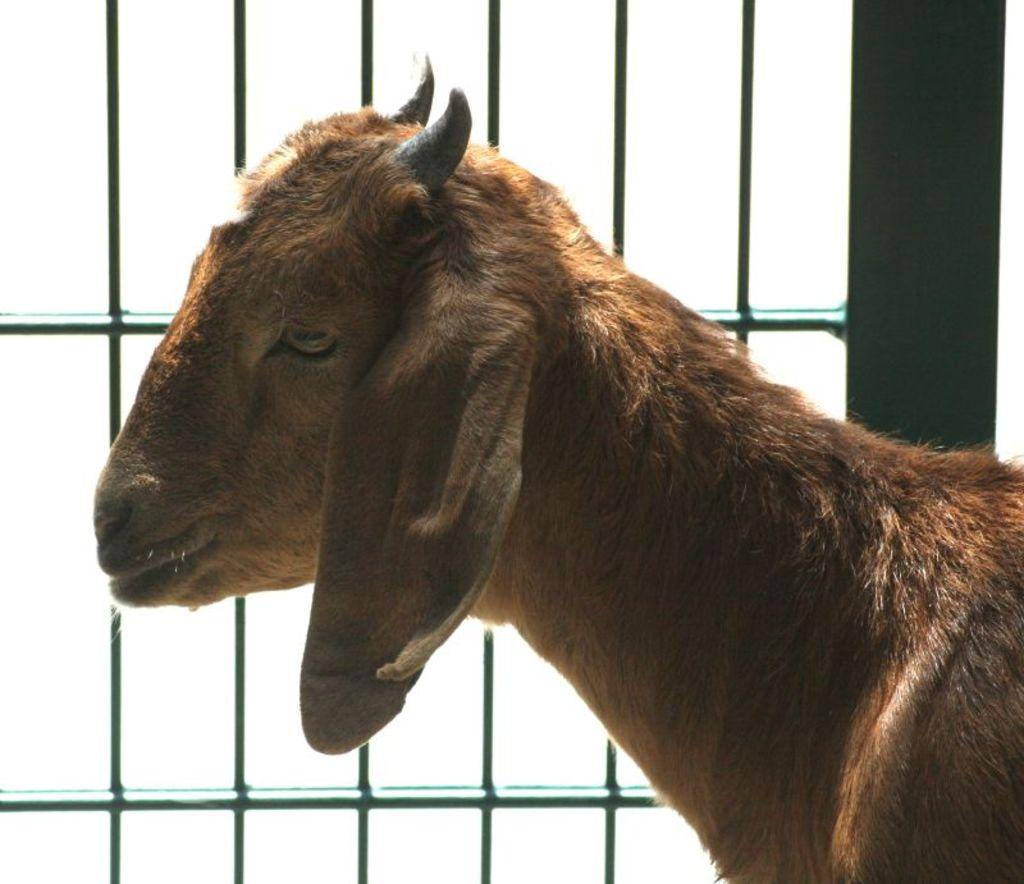What animal is in the picture? There is a goat in the picture. What is the color of the goat? The goat is brown in color. What features can be seen on the goat's head? The goat has ears and horns. What can be seen behind the goat in the picture? There is a part of the railing visible behind the goat. How many feet does the goat have in the picture? Goats have four feet, but the number of feet cannot be determined from the image alone, as only the upper part of the goat is visible. 